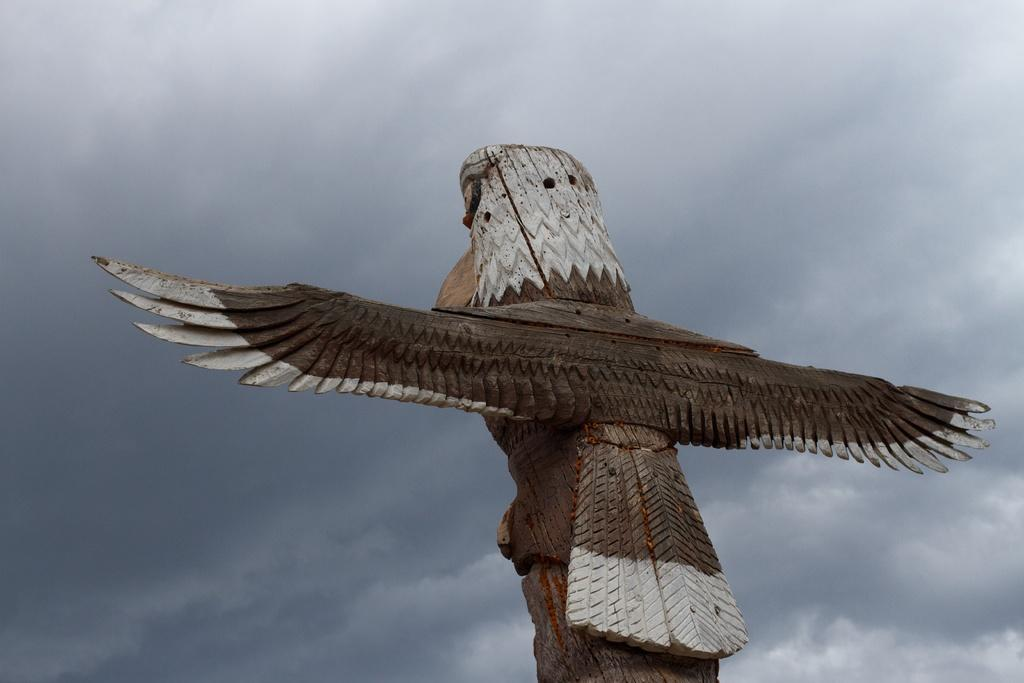What is depicted on the piece of wood in the image? There is a carving of a bird on a piece of wood in the image. What can be seen in the background of the image? The background of the image includes sky. What is visible in the sky? There are clouds visible in the sky. How many children are playing with the vegetable in the image? There are no children or vegetables present in the image. The image features a carving of a carving of a bird on a piece of wood with a sky background that includes clouds. 